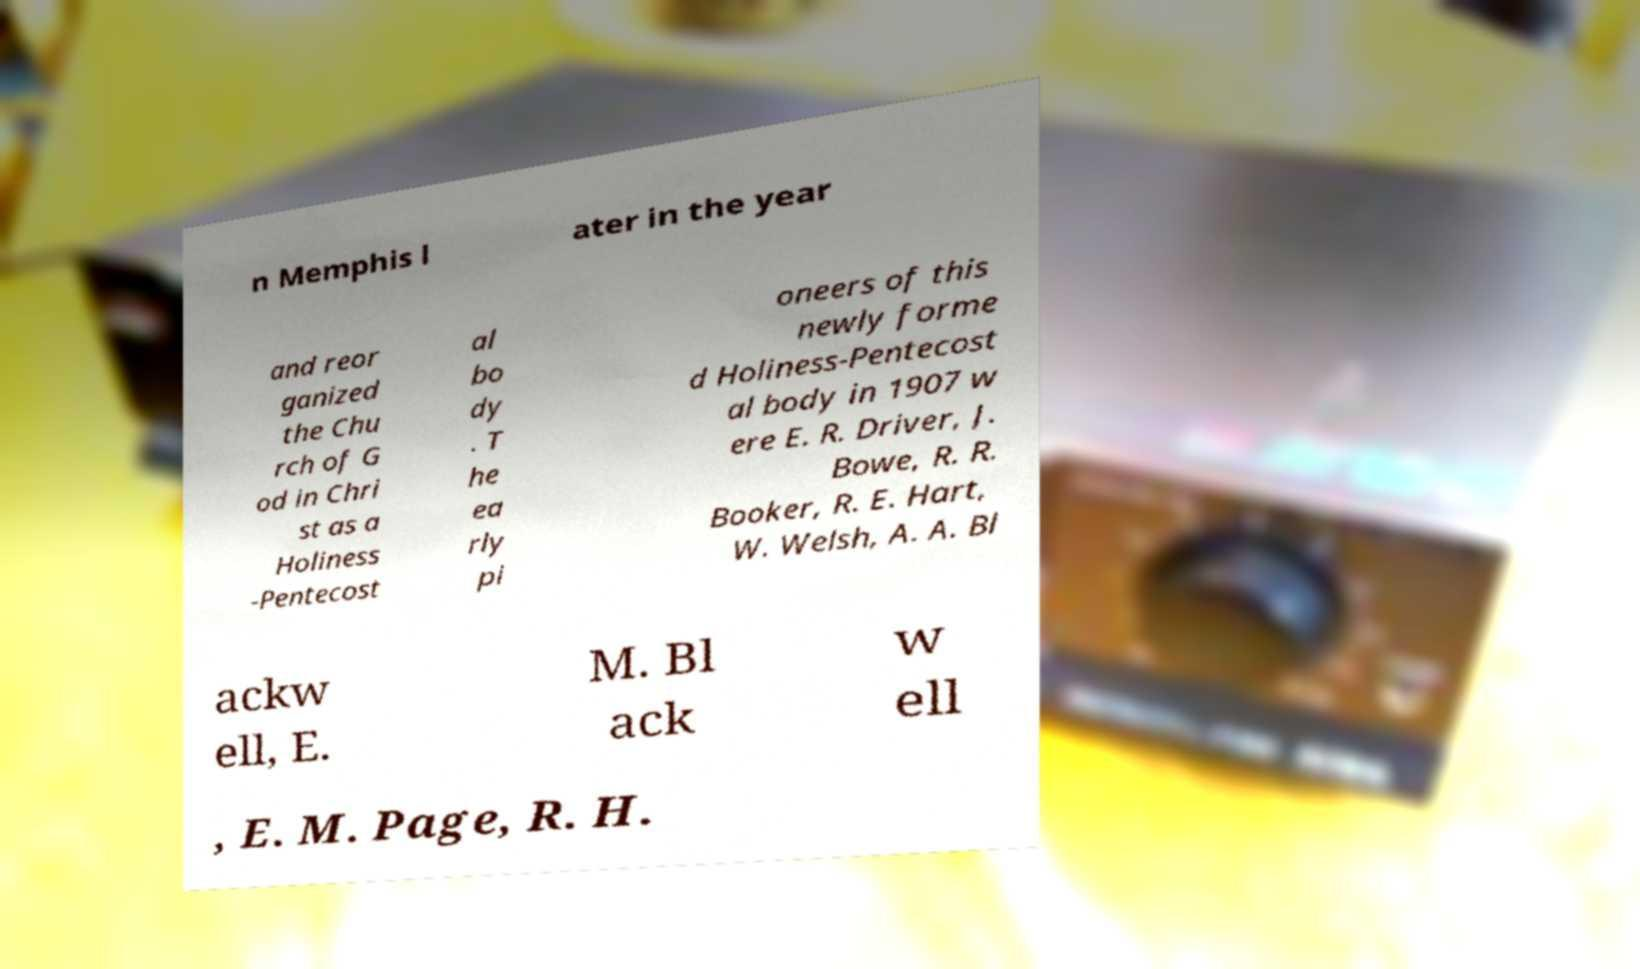For documentation purposes, I need the text within this image transcribed. Could you provide that? n Memphis l ater in the year and reor ganized the Chu rch of G od in Chri st as a Holiness -Pentecost al bo dy . T he ea rly pi oneers of this newly forme d Holiness-Pentecost al body in 1907 w ere E. R. Driver, J. Bowe, R. R. Booker, R. E. Hart, W. Welsh, A. A. Bl ackw ell, E. M. Bl ack w ell , E. M. Page, R. H. 